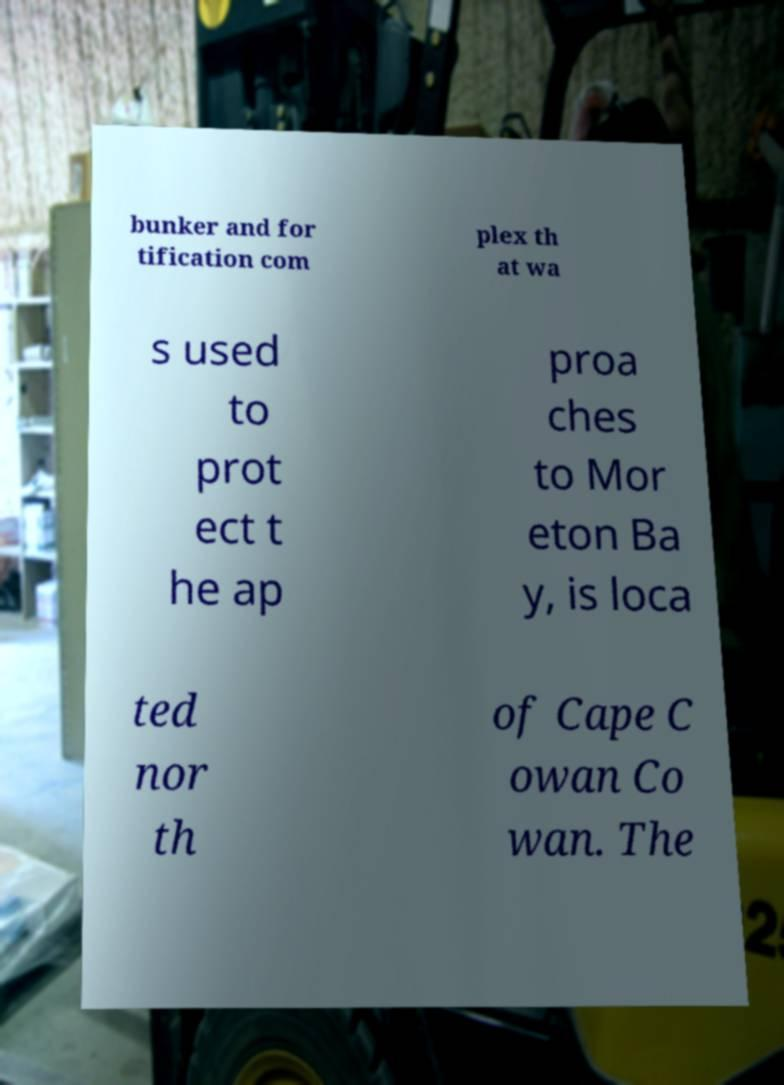Can you accurately transcribe the text from the provided image for me? bunker and for tification com plex th at wa s used to prot ect t he ap proa ches to Mor eton Ba y, is loca ted nor th of Cape C owan Co wan. The 